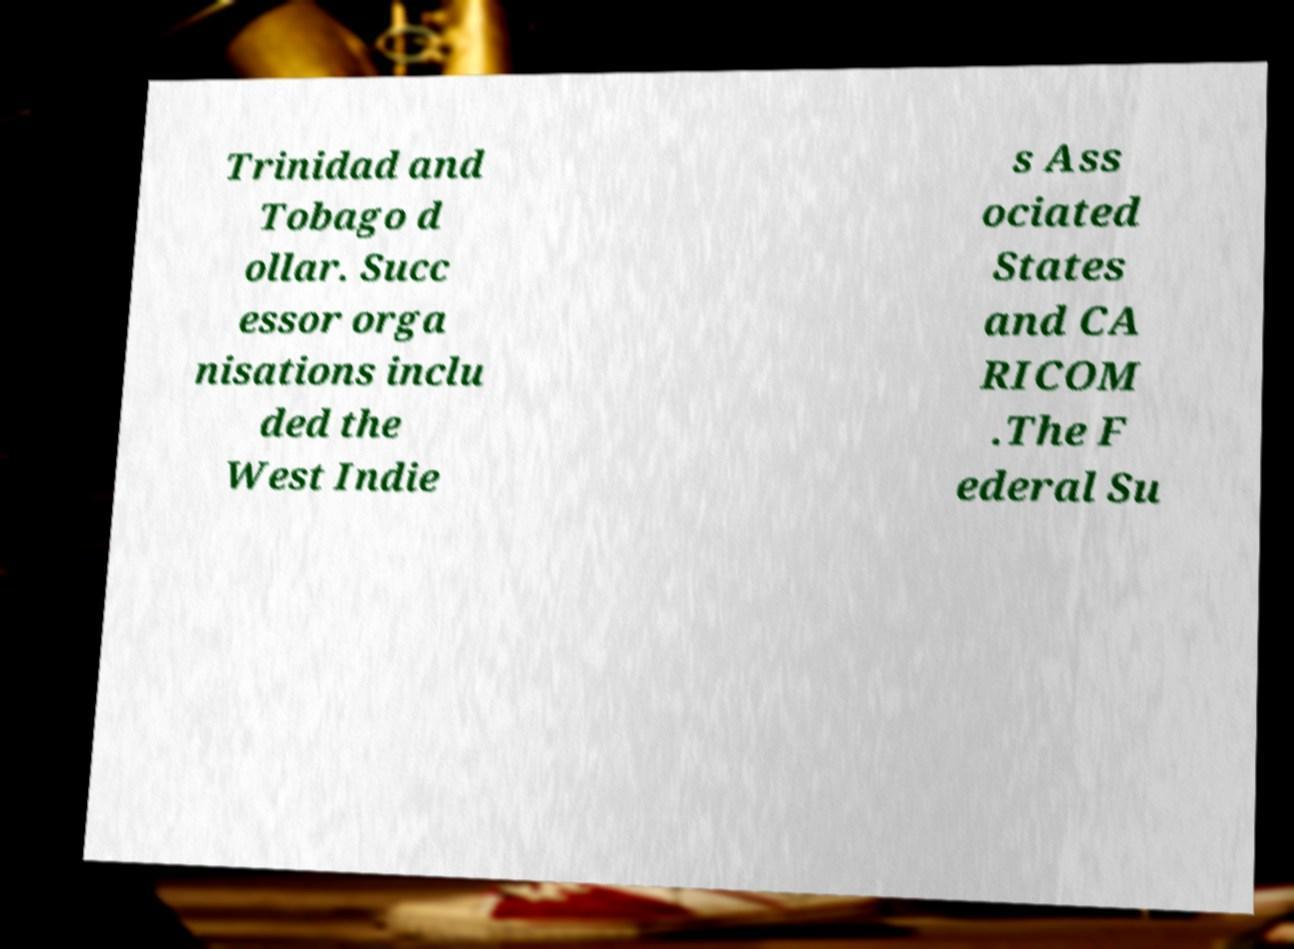There's text embedded in this image that I need extracted. Can you transcribe it verbatim? Trinidad and Tobago d ollar. Succ essor orga nisations inclu ded the West Indie s Ass ociated States and CA RICOM .The F ederal Su 